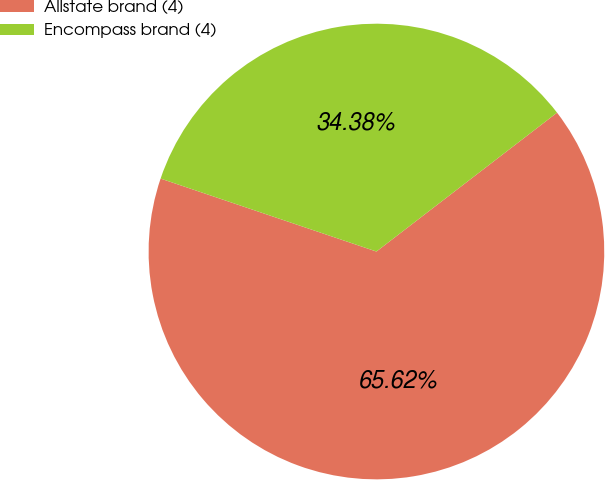<chart> <loc_0><loc_0><loc_500><loc_500><pie_chart><fcel>Allstate brand (4)<fcel>Encompass brand (4)<nl><fcel>65.62%<fcel>34.38%<nl></chart> 